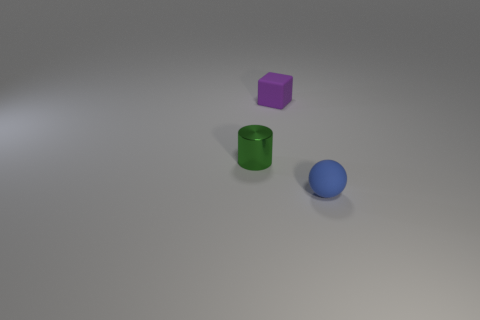Add 3 small purple matte cubes. How many objects exist? 6 Subtract all cubes. How many objects are left? 2 Add 2 blue rubber objects. How many blue rubber objects exist? 3 Subtract 0 gray cylinders. How many objects are left? 3 Subtract all tiny red cubes. Subtract all green objects. How many objects are left? 2 Add 2 green objects. How many green objects are left? 3 